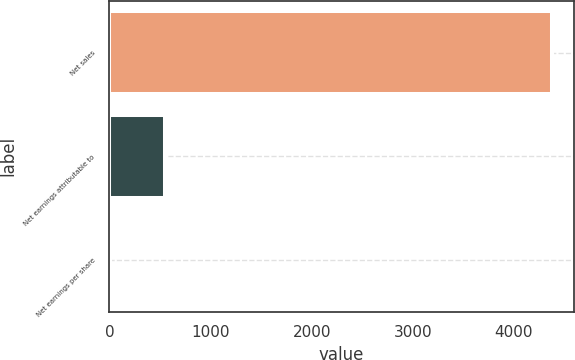Convert chart to OTSL. <chart><loc_0><loc_0><loc_500><loc_500><bar_chart><fcel>Net sales<fcel>Net earnings attributable to<fcel>Net earnings per share<nl><fcel>4373.9<fcel>553.9<fcel>7.71<nl></chart> 